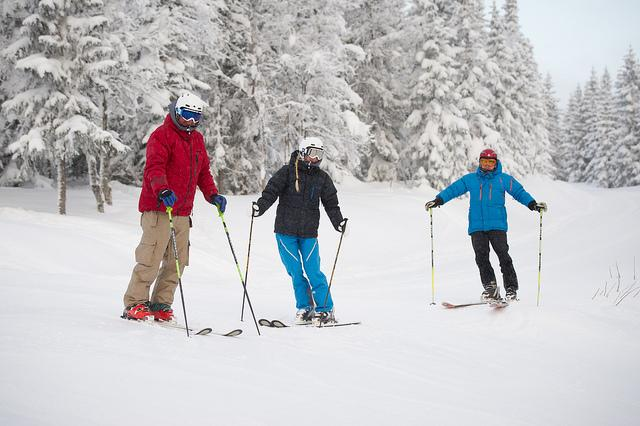A snowblade is made of what?

Choices:
A) wood
B) plastic
C) aluminum
D) copper wood 